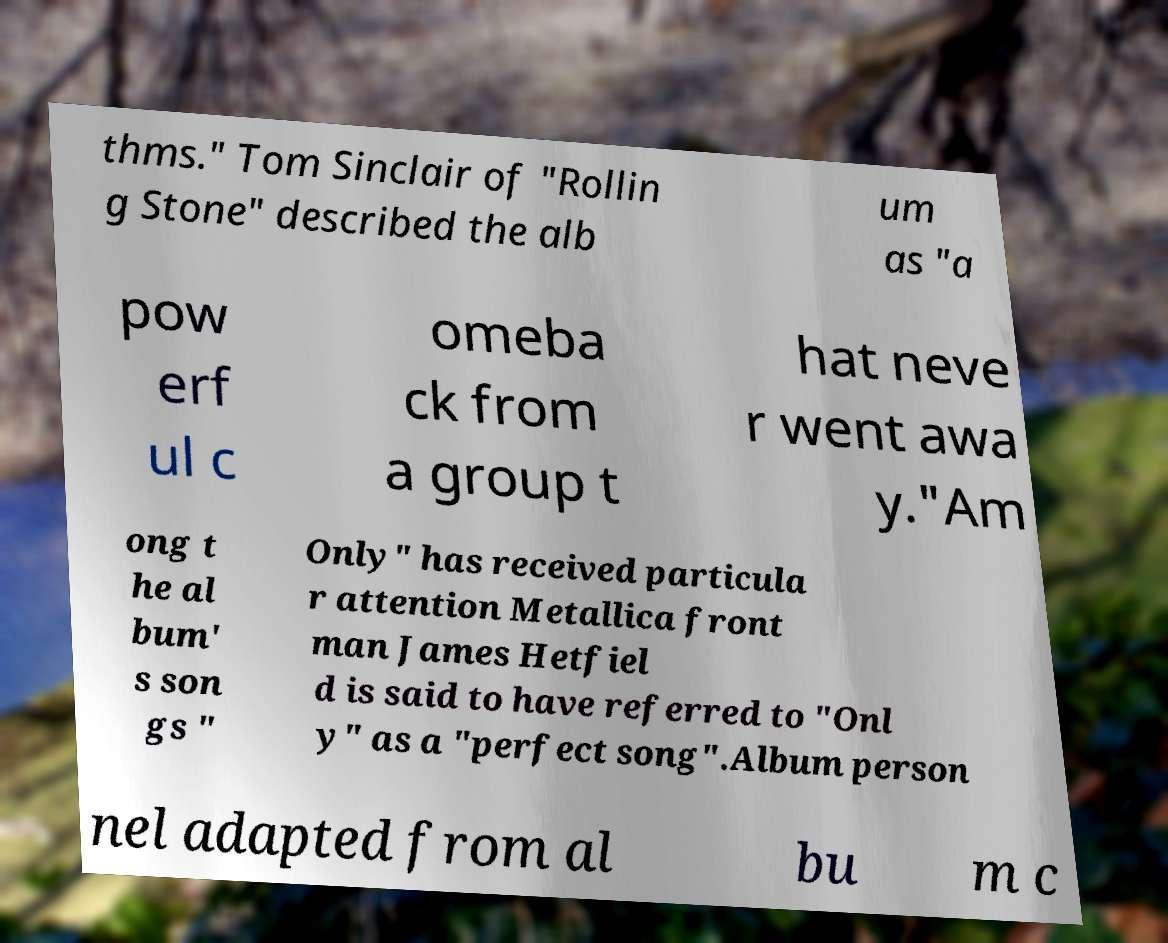Could you extract and type out the text from this image? thms." Tom Sinclair of "Rollin g Stone" described the alb um as "a pow erf ul c omeba ck from a group t hat neve r went awa y."Am ong t he al bum' s son gs " Only" has received particula r attention Metallica front man James Hetfiel d is said to have referred to "Onl y" as a "perfect song".Album person nel adapted from al bu m c 